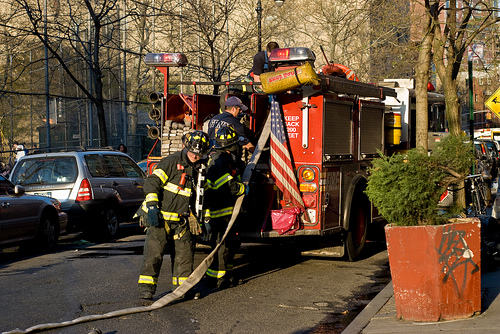<image>
Is there a hose in the fire truck? Yes. The hose is contained within or inside the fire truck, showing a containment relationship. 